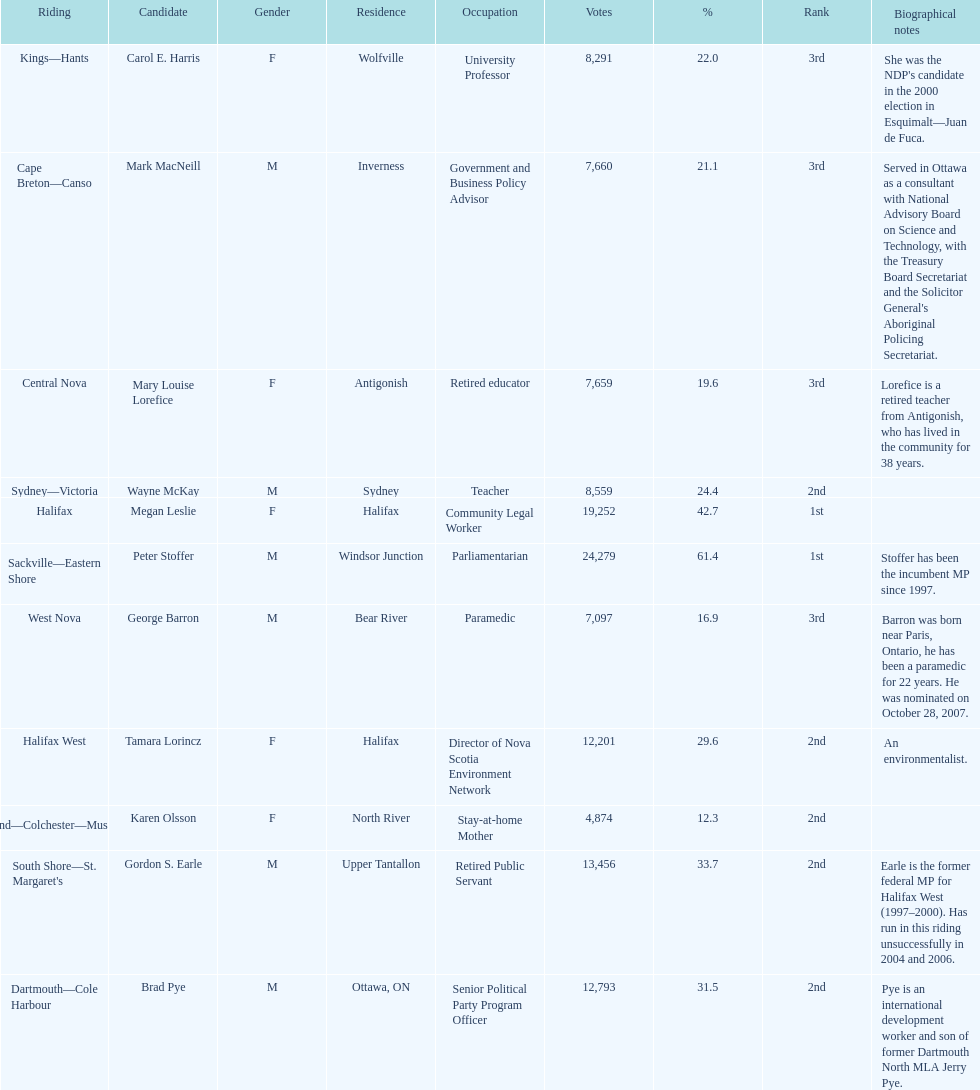How many candidates had more votes than tamara lorincz? 4. 